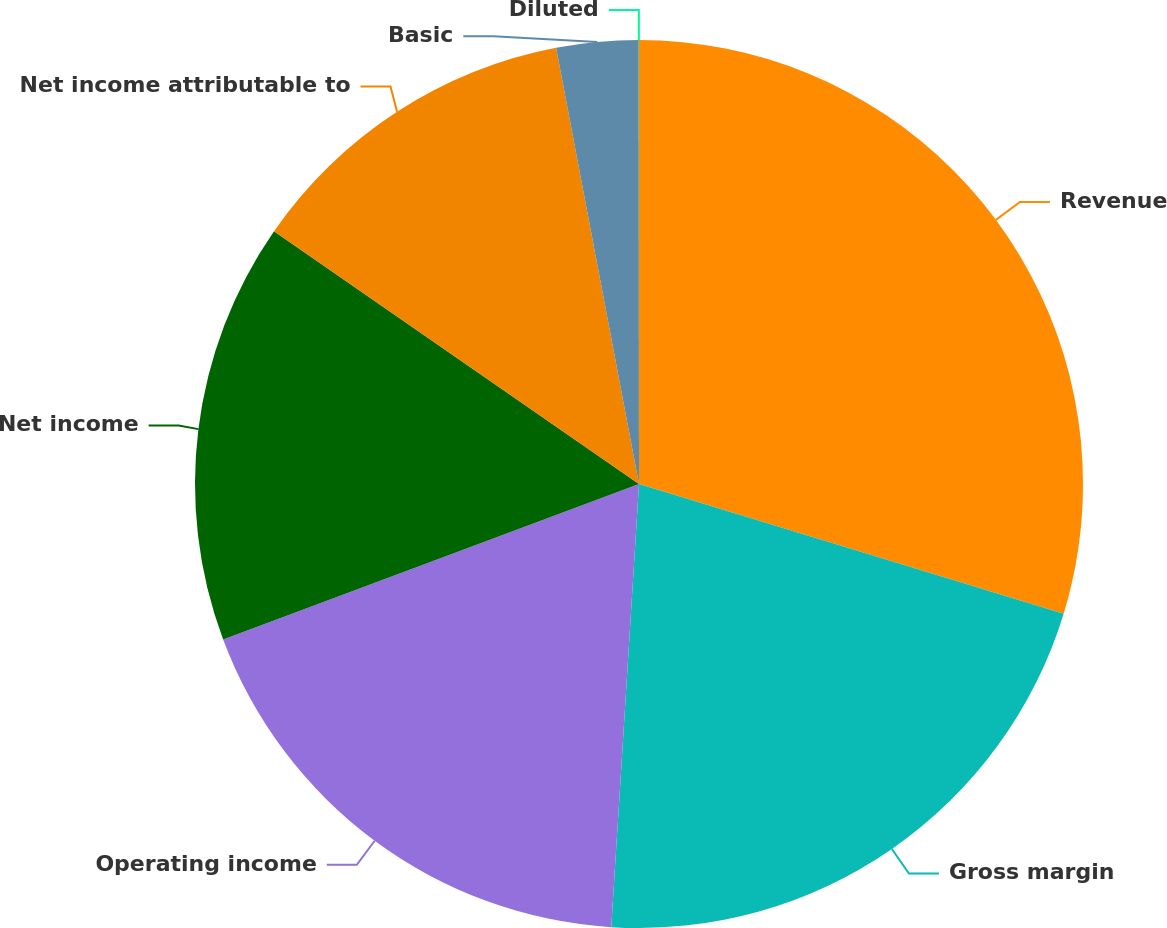<chart> <loc_0><loc_0><loc_500><loc_500><pie_chart><fcel>Revenue<fcel>Gross margin<fcel>Operating income<fcel>Net income<fcel>Net income attributable to<fcel>Basic<fcel>Diluted<nl><fcel>29.72%<fcel>21.28%<fcel>18.31%<fcel>15.34%<fcel>12.37%<fcel>2.98%<fcel>0.01%<nl></chart> 